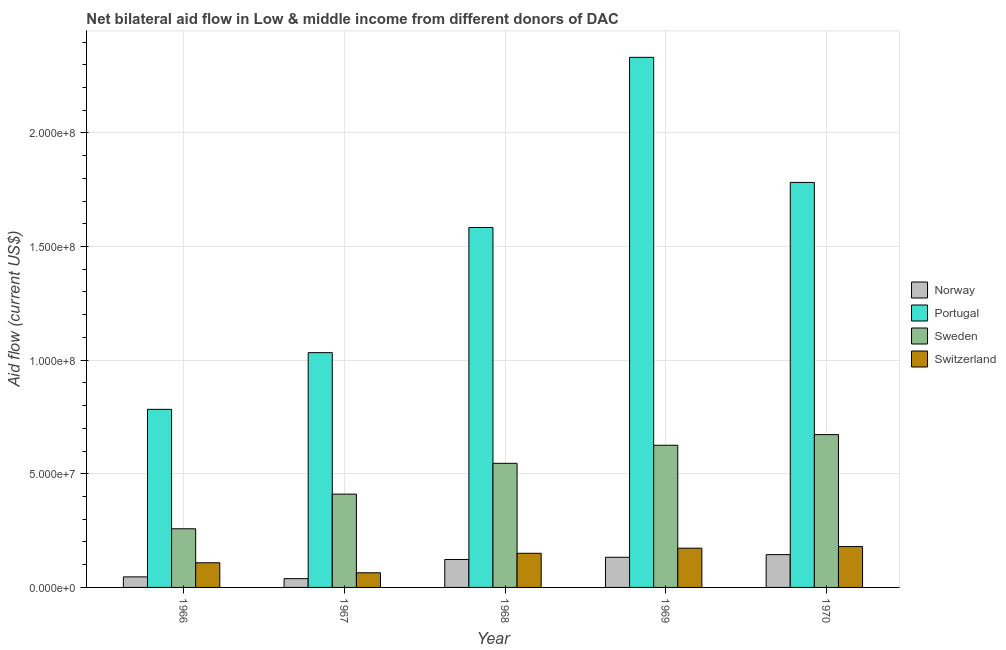How many different coloured bars are there?
Your response must be concise. 4. How many groups of bars are there?
Ensure brevity in your answer.  5. Are the number of bars per tick equal to the number of legend labels?
Ensure brevity in your answer.  Yes. Are the number of bars on each tick of the X-axis equal?
Ensure brevity in your answer.  Yes. How many bars are there on the 2nd tick from the right?
Offer a very short reply. 4. What is the label of the 1st group of bars from the left?
Provide a short and direct response. 1966. What is the amount of aid given by switzerland in 1967?
Offer a terse response. 6.44e+06. Across all years, what is the maximum amount of aid given by sweden?
Your answer should be compact. 6.72e+07. Across all years, what is the minimum amount of aid given by norway?
Ensure brevity in your answer.  3.86e+06. In which year was the amount of aid given by norway minimum?
Your answer should be compact. 1967. What is the total amount of aid given by switzerland in the graph?
Provide a succinct answer. 6.76e+07. What is the difference between the amount of aid given by sweden in 1967 and that in 1970?
Give a very brief answer. -2.62e+07. What is the difference between the amount of aid given by norway in 1967 and the amount of aid given by portugal in 1968?
Offer a very short reply. -8.44e+06. What is the average amount of aid given by sweden per year?
Ensure brevity in your answer.  5.03e+07. What is the ratio of the amount of aid given by switzerland in 1966 to that in 1969?
Ensure brevity in your answer.  0.63. What is the difference between the highest and the second highest amount of aid given by switzerland?
Offer a terse response. 7.20e+05. What is the difference between the highest and the lowest amount of aid given by norway?
Offer a very short reply. 1.06e+07. Is the sum of the amount of aid given by norway in 1968 and 1970 greater than the maximum amount of aid given by portugal across all years?
Keep it short and to the point. Yes. What does the 2nd bar from the left in 1967 represents?
Ensure brevity in your answer.  Portugal. Is it the case that in every year, the sum of the amount of aid given by norway and amount of aid given by portugal is greater than the amount of aid given by sweden?
Offer a terse response. Yes. How many bars are there?
Provide a short and direct response. 20. What is the difference between two consecutive major ticks on the Y-axis?
Make the answer very short. 5.00e+07. Are the values on the major ticks of Y-axis written in scientific E-notation?
Your answer should be compact. Yes. What is the title of the graph?
Provide a succinct answer. Net bilateral aid flow in Low & middle income from different donors of DAC. What is the Aid flow (current US$) of Norway in 1966?
Your response must be concise. 4.64e+06. What is the Aid flow (current US$) in Portugal in 1966?
Your response must be concise. 7.84e+07. What is the Aid flow (current US$) in Sweden in 1966?
Your response must be concise. 2.58e+07. What is the Aid flow (current US$) in Switzerland in 1966?
Ensure brevity in your answer.  1.08e+07. What is the Aid flow (current US$) of Norway in 1967?
Ensure brevity in your answer.  3.86e+06. What is the Aid flow (current US$) of Portugal in 1967?
Keep it short and to the point. 1.03e+08. What is the Aid flow (current US$) of Sweden in 1967?
Make the answer very short. 4.11e+07. What is the Aid flow (current US$) of Switzerland in 1967?
Your answer should be compact. 6.44e+06. What is the Aid flow (current US$) in Norway in 1968?
Your answer should be compact. 1.23e+07. What is the Aid flow (current US$) in Portugal in 1968?
Ensure brevity in your answer.  1.58e+08. What is the Aid flow (current US$) of Sweden in 1968?
Keep it short and to the point. 5.46e+07. What is the Aid flow (current US$) in Switzerland in 1968?
Provide a succinct answer. 1.50e+07. What is the Aid flow (current US$) of Norway in 1969?
Keep it short and to the point. 1.33e+07. What is the Aid flow (current US$) of Portugal in 1969?
Keep it short and to the point. 2.33e+08. What is the Aid flow (current US$) of Sweden in 1969?
Your answer should be very brief. 6.26e+07. What is the Aid flow (current US$) in Switzerland in 1969?
Your answer should be very brief. 1.73e+07. What is the Aid flow (current US$) in Norway in 1970?
Keep it short and to the point. 1.44e+07. What is the Aid flow (current US$) of Portugal in 1970?
Offer a very short reply. 1.78e+08. What is the Aid flow (current US$) in Sweden in 1970?
Provide a succinct answer. 6.72e+07. What is the Aid flow (current US$) of Switzerland in 1970?
Offer a very short reply. 1.80e+07. Across all years, what is the maximum Aid flow (current US$) of Norway?
Keep it short and to the point. 1.44e+07. Across all years, what is the maximum Aid flow (current US$) in Portugal?
Offer a terse response. 2.33e+08. Across all years, what is the maximum Aid flow (current US$) in Sweden?
Your answer should be very brief. 6.72e+07. Across all years, what is the maximum Aid flow (current US$) of Switzerland?
Provide a succinct answer. 1.80e+07. Across all years, what is the minimum Aid flow (current US$) in Norway?
Keep it short and to the point. 3.86e+06. Across all years, what is the minimum Aid flow (current US$) in Portugal?
Offer a terse response. 7.84e+07. Across all years, what is the minimum Aid flow (current US$) in Sweden?
Your response must be concise. 2.58e+07. Across all years, what is the minimum Aid flow (current US$) of Switzerland?
Provide a succinct answer. 6.44e+06. What is the total Aid flow (current US$) of Norway in the graph?
Offer a terse response. 4.85e+07. What is the total Aid flow (current US$) in Portugal in the graph?
Offer a terse response. 7.52e+08. What is the total Aid flow (current US$) of Sweden in the graph?
Provide a succinct answer. 2.51e+08. What is the total Aid flow (current US$) of Switzerland in the graph?
Provide a short and direct response. 6.76e+07. What is the difference between the Aid flow (current US$) of Norway in 1966 and that in 1967?
Offer a terse response. 7.80e+05. What is the difference between the Aid flow (current US$) of Portugal in 1966 and that in 1967?
Your answer should be compact. -2.50e+07. What is the difference between the Aid flow (current US$) of Sweden in 1966 and that in 1967?
Your response must be concise. -1.52e+07. What is the difference between the Aid flow (current US$) in Switzerland in 1966 and that in 1967?
Offer a terse response. 4.41e+06. What is the difference between the Aid flow (current US$) in Norway in 1966 and that in 1968?
Your answer should be very brief. -7.66e+06. What is the difference between the Aid flow (current US$) of Portugal in 1966 and that in 1968?
Provide a succinct answer. -8.00e+07. What is the difference between the Aid flow (current US$) of Sweden in 1966 and that in 1968?
Offer a terse response. -2.88e+07. What is the difference between the Aid flow (current US$) of Switzerland in 1966 and that in 1968?
Make the answer very short. -4.17e+06. What is the difference between the Aid flow (current US$) of Norway in 1966 and that in 1969?
Provide a succinct answer. -8.63e+06. What is the difference between the Aid flow (current US$) in Portugal in 1966 and that in 1969?
Ensure brevity in your answer.  -1.55e+08. What is the difference between the Aid flow (current US$) of Sweden in 1966 and that in 1969?
Keep it short and to the point. -3.68e+07. What is the difference between the Aid flow (current US$) in Switzerland in 1966 and that in 1969?
Give a very brief answer. -6.41e+06. What is the difference between the Aid flow (current US$) of Norway in 1966 and that in 1970?
Offer a terse response. -9.79e+06. What is the difference between the Aid flow (current US$) in Portugal in 1966 and that in 1970?
Ensure brevity in your answer.  -9.98e+07. What is the difference between the Aid flow (current US$) in Sweden in 1966 and that in 1970?
Make the answer very short. -4.14e+07. What is the difference between the Aid flow (current US$) in Switzerland in 1966 and that in 1970?
Provide a short and direct response. -7.13e+06. What is the difference between the Aid flow (current US$) of Norway in 1967 and that in 1968?
Ensure brevity in your answer.  -8.44e+06. What is the difference between the Aid flow (current US$) in Portugal in 1967 and that in 1968?
Give a very brief answer. -5.51e+07. What is the difference between the Aid flow (current US$) in Sweden in 1967 and that in 1968?
Provide a short and direct response. -1.36e+07. What is the difference between the Aid flow (current US$) in Switzerland in 1967 and that in 1968?
Give a very brief answer. -8.58e+06. What is the difference between the Aid flow (current US$) in Norway in 1967 and that in 1969?
Offer a terse response. -9.41e+06. What is the difference between the Aid flow (current US$) of Portugal in 1967 and that in 1969?
Your answer should be very brief. -1.30e+08. What is the difference between the Aid flow (current US$) of Sweden in 1967 and that in 1969?
Give a very brief answer. -2.15e+07. What is the difference between the Aid flow (current US$) in Switzerland in 1967 and that in 1969?
Provide a short and direct response. -1.08e+07. What is the difference between the Aid flow (current US$) in Norway in 1967 and that in 1970?
Make the answer very short. -1.06e+07. What is the difference between the Aid flow (current US$) in Portugal in 1967 and that in 1970?
Ensure brevity in your answer.  -7.49e+07. What is the difference between the Aid flow (current US$) in Sweden in 1967 and that in 1970?
Make the answer very short. -2.62e+07. What is the difference between the Aid flow (current US$) in Switzerland in 1967 and that in 1970?
Ensure brevity in your answer.  -1.15e+07. What is the difference between the Aid flow (current US$) in Norway in 1968 and that in 1969?
Your answer should be compact. -9.70e+05. What is the difference between the Aid flow (current US$) of Portugal in 1968 and that in 1969?
Make the answer very short. -7.49e+07. What is the difference between the Aid flow (current US$) in Sweden in 1968 and that in 1969?
Provide a short and direct response. -7.95e+06. What is the difference between the Aid flow (current US$) in Switzerland in 1968 and that in 1969?
Your answer should be very brief. -2.24e+06. What is the difference between the Aid flow (current US$) of Norway in 1968 and that in 1970?
Offer a very short reply. -2.13e+06. What is the difference between the Aid flow (current US$) in Portugal in 1968 and that in 1970?
Offer a terse response. -1.98e+07. What is the difference between the Aid flow (current US$) of Sweden in 1968 and that in 1970?
Ensure brevity in your answer.  -1.26e+07. What is the difference between the Aid flow (current US$) in Switzerland in 1968 and that in 1970?
Your response must be concise. -2.96e+06. What is the difference between the Aid flow (current US$) in Norway in 1969 and that in 1970?
Your answer should be compact. -1.16e+06. What is the difference between the Aid flow (current US$) in Portugal in 1969 and that in 1970?
Offer a very short reply. 5.50e+07. What is the difference between the Aid flow (current US$) of Sweden in 1969 and that in 1970?
Provide a succinct answer. -4.68e+06. What is the difference between the Aid flow (current US$) of Switzerland in 1969 and that in 1970?
Provide a short and direct response. -7.20e+05. What is the difference between the Aid flow (current US$) in Norway in 1966 and the Aid flow (current US$) in Portugal in 1967?
Keep it short and to the point. -9.87e+07. What is the difference between the Aid flow (current US$) in Norway in 1966 and the Aid flow (current US$) in Sweden in 1967?
Your answer should be compact. -3.64e+07. What is the difference between the Aid flow (current US$) in Norway in 1966 and the Aid flow (current US$) in Switzerland in 1967?
Your answer should be very brief. -1.80e+06. What is the difference between the Aid flow (current US$) of Portugal in 1966 and the Aid flow (current US$) of Sweden in 1967?
Offer a terse response. 3.73e+07. What is the difference between the Aid flow (current US$) of Portugal in 1966 and the Aid flow (current US$) of Switzerland in 1967?
Provide a short and direct response. 7.19e+07. What is the difference between the Aid flow (current US$) in Sweden in 1966 and the Aid flow (current US$) in Switzerland in 1967?
Your response must be concise. 1.94e+07. What is the difference between the Aid flow (current US$) of Norway in 1966 and the Aid flow (current US$) of Portugal in 1968?
Provide a succinct answer. -1.54e+08. What is the difference between the Aid flow (current US$) in Norway in 1966 and the Aid flow (current US$) in Sweden in 1968?
Ensure brevity in your answer.  -5.00e+07. What is the difference between the Aid flow (current US$) in Norway in 1966 and the Aid flow (current US$) in Switzerland in 1968?
Your response must be concise. -1.04e+07. What is the difference between the Aid flow (current US$) in Portugal in 1966 and the Aid flow (current US$) in Sweden in 1968?
Offer a very short reply. 2.38e+07. What is the difference between the Aid flow (current US$) in Portugal in 1966 and the Aid flow (current US$) in Switzerland in 1968?
Make the answer very short. 6.33e+07. What is the difference between the Aid flow (current US$) in Sweden in 1966 and the Aid flow (current US$) in Switzerland in 1968?
Provide a succinct answer. 1.08e+07. What is the difference between the Aid flow (current US$) in Norway in 1966 and the Aid flow (current US$) in Portugal in 1969?
Ensure brevity in your answer.  -2.29e+08. What is the difference between the Aid flow (current US$) of Norway in 1966 and the Aid flow (current US$) of Sweden in 1969?
Offer a very short reply. -5.79e+07. What is the difference between the Aid flow (current US$) in Norway in 1966 and the Aid flow (current US$) in Switzerland in 1969?
Keep it short and to the point. -1.26e+07. What is the difference between the Aid flow (current US$) of Portugal in 1966 and the Aid flow (current US$) of Sweden in 1969?
Keep it short and to the point. 1.58e+07. What is the difference between the Aid flow (current US$) in Portugal in 1966 and the Aid flow (current US$) in Switzerland in 1969?
Your response must be concise. 6.11e+07. What is the difference between the Aid flow (current US$) of Sweden in 1966 and the Aid flow (current US$) of Switzerland in 1969?
Provide a succinct answer. 8.55e+06. What is the difference between the Aid flow (current US$) in Norway in 1966 and the Aid flow (current US$) in Portugal in 1970?
Your answer should be very brief. -1.74e+08. What is the difference between the Aid flow (current US$) of Norway in 1966 and the Aid flow (current US$) of Sweden in 1970?
Your answer should be compact. -6.26e+07. What is the difference between the Aid flow (current US$) of Norway in 1966 and the Aid flow (current US$) of Switzerland in 1970?
Keep it short and to the point. -1.33e+07. What is the difference between the Aid flow (current US$) in Portugal in 1966 and the Aid flow (current US$) in Sweden in 1970?
Give a very brief answer. 1.11e+07. What is the difference between the Aid flow (current US$) in Portugal in 1966 and the Aid flow (current US$) in Switzerland in 1970?
Make the answer very short. 6.04e+07. What is the difference between the Aid flow (current US$) in Sweden in 1966 and the Aid flow (current US$) in Switzerland in 1970?
Ensure brevity in your answer.  7.83e+06. What is the difference between the Aid flow (current US$) of Norway in 1967 and the Aid flow (current US$) of Portugal in 1968?
Offer a very short reply. -1.55e+08. What is the difference between the Aid flow (current US$) in Norway in 1967 and the Aid flow (current US$) in Sweden in 1968?
Your response must be concise. -5.08e+07. What is the difference between the Aid flow (current US$) in Norway in 1967 and the Aid flow (current US$) in Switzerland in 1968?
Ensure brevity in your answer.  -1.12e+07. What is the difference between the Aid flow (current US$) in Portugal in 1967 and the Aid flow (current US$) in Sweden in 1968?
Provide a succinct answer. 4.87e+07. What is the difference between the Aid flow (current US$) of Portugal in 1967 and the Aid flow (current US$) of Switzerland in 1968?
Your answer should be very brief. 8.83e+07. What is the difference between the Aid flow (current US$) of Sweden in 1967 and the Aid flow (current US$) of Switzerland in 1968?
Your answer should be very brief. 2.60e+07. What is the difference between the Aid flow (current US$) of Norway in 1967 and the Aid flow (current US$) of Portugal in 1969?
Keep it short and to the point. -2.29e+08. What is the difference between the Aid flow (current US$) of Norway in 1967 and the Aid flow (current US$) of Sweden in 1969?
Offer a terse response. -5.87e+07. What is the difference between the Aid flow (current US$) in Norway in 1967 and the Aid flow (current US$) in Switzerland in 1969?
Keep it short and to the point. -1.34e+07. What is the difference between the Aid flow (current US$) in Portugal in 1967 and the Aid flow (current US$) in Sweden in 1969?
Provide a succinct answer. 4.08e+07. What is the difference between the Aid flow (current US$) in Portugal in 1967 and the Aid flow (current US$) in Switzerland in 1969?
Keep it short and to the point. 8.60e+07. What is the difference between the Aid flow (current US$) in Sweden in 1967 and the Aid flow (current US$) in Switzerland in 1969?
Provide a succinct answer. 2.38e+07. What is the difference between the Aid flow (current US$) of Norway in 1967 and the Aid flow (current US$) of Portugal in 1970?
Make the answer very short. -1.74e+08. What is the difference between the Aid flow (current US$) of Norway in 1967 and the Aid flow (current US$) of Sweden in 1970?
Your answer should be compact. -6.34e+07. What is the difference between the Aid flow (current US$) in Norway in 1967 and the Aid flow (current US$) in Switzerland in 1970?
Your answer should be very brief. -1.41e+07. What is the difference between the Aid flow (current US$) in Portugal in 1967 and the Aid flow (current US$) in Sweden in 1970?
Your answer should be compact. 3.61e+07. What is the difference between the Aid flow (current US$) of Portugal in 1967 and the Aid flow (current US$) of Switzerland in 1970?
Provide a succinct answer. 8.53e+07. What is the difference between the Aid flow (current US$) of Sweden in 1967 and the Aid flow (current US$) of Switzerland in 1970?
Your response must be concise. 2.31e+07. What is the difference between the Aid flow (current US$) of Norway in 1968 and the Aid flow (current US$) of Portugal in 1969?
Offer a terse response. -2.21e+08. What is the difference between the Aid flow (current US$) in Norway in 1968 and the Aid flow (current US$) in Sweden in 1969?
Your answer should be very brief. -5.03e+07. What is the difference between the Aid flow (current US$) of Norway in 1968 and the Aid flow (current US$) of Switzerland in 1969?
Provide a short and direct response. -4.96e+06. What is the difference between the Aid flow (current US$) of Portugal in 1968 and the Aid flow (current US$) of Sweden in 1969?
Your answer should be very brief. 9.58e+07. What is the difference between the Aid flow (current US$) of Portugal in 1968 and the Aid flow (current US$) of Switzerland in 1969?
Provide a succinct answer. 1.41e+08. What is the difference between the Aid flow (current US$) in Sweden in 1968 and the Aid flow (current US$) in Switzerland in 1969?
Make the answer very short. 3.74e+07. What is the difference between the Aid flow (current US$) of Norway in 1968 and the Aid flow (current US$) of Portugal in 1970?
Your answer should be very brief. -1.66e+08. What is the difference between the Aid flow (current US$) in Norway in 1968 and the Aid flow (current US$) in Sweden in 1970?
Your answer should be very brief. -5.49e+07. What is the difference between the Aid flow (current US$) in Norway in 1968 and the Aid flow (current US$) in Switzerland in 1970?
Your answer should be very brief. -5.68e+06. What is the difference between the Aid flow (current US$) in Portugal in 1968 and the Aid flow (current US$) in Sweden in 1970?
Your response must be concise. 9.11e+07. What is the difference between the Aid flow (current US$) in Portugal in 1968 and the Aid flow (current US$) in Switzerland in 1970?
Offer a very short reply. 1.40e+08. What is the difference between the Aid flow (current US$) of Sweden in 1968 and the Aid flow (current US$) of Switzerland in 1970?
Make the answer very short. 3.66e+07. What is the difference between the Aid flow (current US$) in Norway in 1969 and the Aid flow (current US$) in Portugal in 1970?
Give a very brief answer. -1.65e+08. What is the difference between the Aid flow (current US$) of Norway in 1969 and the Aid flow (current US$) of Sweden in 1970?
Offer a terse response. -5.40e+07. What is the difference between the Aid flow (current US$) of Norway in 1969 and the Aid flow (current US$) of Switzerland in 1970?
Give a very brief answer. -4.71e+06. What is the difference between the Aid flow (current US$) in Portugal in 1969 and the Aid flow (current US$) in Sweden in 1970?
Provide a short and direct response. 1.66e+08. What is the difference between the Aid flow (current US$) of Portugal in 1969 and the Aid flow (current US$) of Switzerland in 1970?
Make the answer very short. 2.15e+08. What is the difference between the Aid flow (current US$) in Sweden in 1969 and the Aid flow (current US$) in Switzerland in 1970?
Your answer should be very brief. 4.46e+07. What is the average Aid flow (current US$) in Norway per year?
Your response must be concise. 9.70e+06. What is the average Aid flow (current US$) in Portugal per year?
Keep it short and to the point. 1.50e+08. What is the average Aid flow (current US$) of Sweden per year?
Give a very brief answer. 5.03e+07. What is the average Aid flow (current US$) of Switzerland per year?
Provide a short and direct response. 1.35e+07. In the year 1966, what is the difference between the Aid flow (current US$) in Norway and Aid flow (current US$) in Portugal?
Keep it short and to the point. -7.37e+07. In the year 1966, what is the difference between the Aid flow (current US$) of Norway and Aid flow (current US$) of Sweden?
Give a very brief answer. -2.12e+07. In the year 1966, what is the difference between the Aid flow (current US$) of Norway and Aid flow (current US$) of Switzerland?
Keep it short and to the point. -6.21e+06. In the year 1966, what is the difference between the Aid flow (current US$) of Portugal and Aid flow (current US$) of Sweden?
Offer a terse response. 5.26e+07. In the year 1966, what is the difference between the Aid flow (current US$) in Portugal and Aid flow (current US$) in Switzerland?
Offer a very short reply. 6.75e+07. In the year 1966, what is the difference between the Aid flow (current US$) of Sweden and Aid flow (current US$) of Switzerland?
Provide a short and direct response. 1.50e+07. In the year 1967, what is the difference between the Aid flow (current US$) in Norway and Aid flow (current US$) in Portugal?
Offer a very short reply. -9.94e+07. In the year 1967, what is the difference between the Aid flow (current US$) of Norway and Aid flow (current US$) of Sweden?
Make the answer very short. -3.72e+07. In the year 1967, what is the difference between the Aid flow (current US$) in Norway and Aid flow (current US$) in Switzerland?
Ensure brevity in your answer.  -2.58e+06. In the year 1967, what is the difference between the Aid flow (current US$) in Portugal and Aid flow (current US$) in Sweden?
Make the answer very short. 6.22e+07. In the year 1967, what is the difference between the Aid flow (current US$) of Portugal and Aid flow (current US$) of Switzerland?
Your answer should be compact. 9.69e+07. In the year 1967, what is the difference between the Aid flow (current US$) of Sweden and Aid flow (current US$) of Switzerland?
Provide a short and direct response. 3.46e+07. In the year 1968, what is the difference between the Aid flow (current US$) of Norway and Aid flow (current US$) of Portugal?
Ensure brevity in your answer.  -1.46e+08. In the year 1968, what is the difference between the Aid flow (current US$) in Norway and Aid flow (current US$) in Sweden?
Your response must be concise. -4.23e+07. In the year 1968, what is the difference between the Aid flow (current US$) in Norway and Aid flow (current US$) in Switzerland?
Your answer should be very brief. -2.72e+06. In the year 1968, what is the difference between the Aid flow (current US$) in Portugal and Aid flow (current US$) in Sweden?
Offer a very short reply. 1.04e+08. In the year 1968, what is the difference between the Aid flow (current US$) of Portugal and Aid flow (current US$) of Switzerland?
Ensure brevity in your answer.  1.43e+08. In the year 1968, what is the difference between the Aid flow (current US$) in Sweden and Aid flow (current US$) in Switzerland?
Give a very brief answer. 3.96e+07. In the year 1969, what is the difference between the Aid flow (current US$) of Norway and Aid flow (current US$) of Portugal?
Your answer should be very brief. -2.20e+08. In the year 1969, what is the difference between the Aid flow (current US$) in Norway and Aid flow (current US$) in Sweden?
Offer a very short reply. -4.93e+07. In the year 1969, what is the difference between the Aid flow (current US$) of Norway and Aid flow (current US$) of Switzerland?
Make the answer very short. -3.99e+06. In the year 1969, what is the difference between the Aid flow (current US$) in Portugal and Aid flow (current US$) in Sweden?
Your answer should be compact. 1.71e+08. In the year 1969, what is the difference between the Aid flow (current US$) of Portugal and Aid flow (current US$) of Switzerland?
Offer a very short reply. 2.16e+08. In the year 1969, what is the difference between the Aid flow (current US$) of Sweden and Aid flow (current US$) of Switzerland?
Your response must be concise. 4.53e+07. In the year 1970, what is the difference between the Aid flow (current US$) of Norway and Aid flow (current US$) of Portugal?
Provide a succinct answer. -1.64e+08. In the year 1970, what is the difference between the Aid flow (current US$) in Norway and Aid flow (current US$) in Sweden?
Ensure brevity in your answer.  -5.28e+07. In the year 1970, what is the difference between the Aid flow (current US$) of Norway and Aid flow (current US$) of Switzerland?
Keep it short and to the point. -3.55e+06. In the year 1970, what is the difference between the Aid flow (current US$) in Portugal and Aid flow (current US$) in Sweden?
Provide a succinct answer. 1.11e+08. In the year 1970, what is the difference between the Aid flow (current US$) of Portugal and Aid flow (current US$) of Switzerland?
Give a very brief answer. 1.60e+08. In the year 1970, what is the difference between the Aid flow (current US$) in Sweden and Aid flow (current US$) in Switzerland?
Offer a very short reply. 4.93e+07. What is the ratio of the Aid flow (current US$) of Norway in 1966 to that in 1967?
Make the answer very short. 1.2. What is the ratio of the Aid flow (current US$) of Portugal in 1966 to that in 1967?
Offer a terse response. 0.76. What is the ratio of the Aid flow (current US$) of Sweden in 1966 to that in 1967?
Offer a very short reply. 0.63. What is the ratio of the Aid flow (current US$) of Switzerland in 1966 to that in 1967?
Your answer should be very brief. 1.68. What is the ratio of the Aid flow (current US$) of Norway in 1966 to that in 1968?
Your answer should be compact. 0.38. What is the ratio of the Aid flow (current US$) in Portugal in 1966 to that in 1968?
Provide a short and direct response. 0.49. What is the ratio of the Aid flow (current US$) of Sweden in 1966 to that in 1968?
Your answer should be very brief. 0.47. What is the ratio of the Aid flow (current US$) of Switzerland in 1966 to that in 1968?
Make the answer very short. 0.72. What is the ratio of the Aid flow (current US$) in Norway in 1966 to that in 1969?
Offer a terse response. 0.35. What is the ratio of the Aid flow (current US$) of Portugal in 1966 to that in 1969?
Offer a very short reply. 0.34. What is the ratio of the Aid flow (current US$) in Sweden in 1966 to that in 1969?
Offer a very short reply. 0.41. What is the ratio of the Aid flow (current US$) in Switzerland in 1966 to that in 1969?
Ensure brevity in your answer.  0.63. What is the ratio of the Aid flow (current US$) in Norway in 1966 to that in 1970?
Your answer should be very brief. 0.32. What is the ratio of the Aid flow (current US$) of Portugal in 1966 to that in 1970?
Ensure brevity in your answer.  0.44. What is the ratio of the Aid flow (current US$) of Sweden in 1966 to that in 1970?
Offer a very short reply. 0.38. What is the ratio of the Aid flow (current US$) of Switzerland in 1966 to that in 1970?
Give a very brief answer. 0.6. What is the ratio of the Aid flow (current US$) of Norway in 1967 to that in 1968?
Offer a terse response. 0.31. What is the ratio of the Aid flow (current US$) of Portugal in 1967 to that in 1968?
Offer a terse response. 0.65. What is the ratio of the Aid flow (current US$) in Sweden in 1967 to that in 1968?
Your response must be concise. 0.75. What is the ratio of the Aid flow (current US$) in Switzerland in 1967 to that in 1968?
Offer a terse response. 0.43. What is the ratio of the Aid flow (current US$) in Norway in 1967 to that in 1969?
Make the answer very short. 0.29. What is the ratio of the Aid flow (current US$) in Portugal in 1967 to that in 1969?
Your response must be concise. 0.44. What is the ratio of the Aid flow (current US$) of Sweden in 1967 to that in 1969?
Offer a very short reply. 0.66. What is the ratio of the Aid flow (current US$) of Switzerland in 1967 to that in 1969?
Keep it short and to the point. 0.37. What is the ratio of the Aid flow (current US$) in Norway in 1967 to that in 1970?
Ensure brevity in your answer.  0.27. What is the ratio of the Aid flow (current US$) in Portugal in 1967 to that in 1970?
Ensure brevity in your answer.  0.58. What is the ratio of the Aid flow (current US$) of Sweden in 1967 to that in 1970?
Your answer should be compact. 0.61. What is the ratio of the Aid flow (current US$) of Switzerland in 1967 to that in 1970?
Keep it short and to the point. 0.36. What is the ratio of the Aid flow (current US$) in Norway in 1968 to that in 1969?
Make the answer very short. 0.93. What is the ratio of the Aid flow (current US$) of Portugal in 1968 to that in 1969?
Your answer should be very brief. 0.68. What is the ratio of the Aid flow (current US$) in Sweden in 1968 to that in 1969?
Your response must be concise. 0.87. What is the ratio of the Aid flow (current US$) of Switzerland in 1968 to that in 1969?
Provide a succinct answer. 0.87. What is the ratio of the Aid flow (current US$) in Norway in 1968 to that in 1970?
Your answer should be very brief. 0.85. What is the ratio of the Aid flow (current US$) in Portugal in 1968 to that in 1970?
Ensure brevity in your answer.  0.89. What is the ratio of the Aid flow (current US$) in Sweden in 1968 to that in 1970?
Your answer should be compact. 0.81. What is the ratio of the Aid flow (current US$) of Switzerland in 1968 to that in 1970?
Make the answer very short. 0.84. What is the ratio of the Aid flow (current US$) in Norway in 1969 to that in 1970?
Ensure brevity in your answer.  0.92. What is the ratio of the Aid flow (current US$) in Portugal in 1969 to that in 1970?
Provide a succinct answer. 1.31. What is the ratio of the Aid flow (current US$) of Sweden in 1969 to that in 1970?
Give a very brief answer. 0.93. What is the ratio of the Aid flow (current US$) in Switzerland in 1969 to that in 1970?
Provide a short and direct response. 0.96. What is the difference between the highest and the second highest Aid flow (current US$) of Norway?
Your answer should be very brief. 1.16e+06. What is the difference between the highest and the second highest Aid flow (current US$) of Portugal?
Provide a succinct answer. 5.50e+07. What is the difference between the highest and the second highest Aid flow (current US$) in Sweden?
Offer a very short reply. 4.68e+06. What is the difference between the highest and the second highest Aid flow (current US$) of Switzerland?
Provide a succinct answer. 7.20e+05. What is the difference between the highest and the lowest Aid flow (current US$) of Norway?
Offer a very short reply. 1.06e+07. What is the difference between the highest and the lowest Aid flow (current US$) in Portugal?
Offer a terse response. 1.55e+08. What is the difference between the highest and the lowest Aid flow (current US$) of Sweden?
Your answer should be very brief. 4.14e+07. What is the difference between the highest and the lowest Aid flow (current US$) in Switzerland?
Provide a short and direct response. 1.15e+07. 